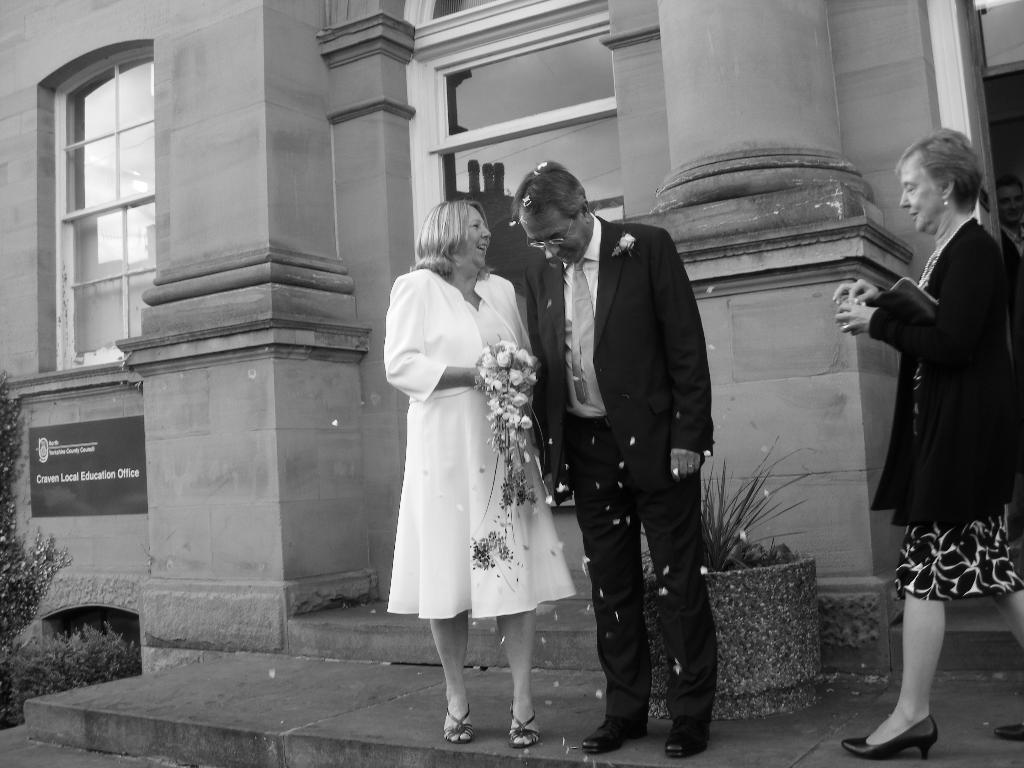Please provide a concise description of this image. In this picture we can see three people,one woman is holding flowers and in the background we can see a building. 